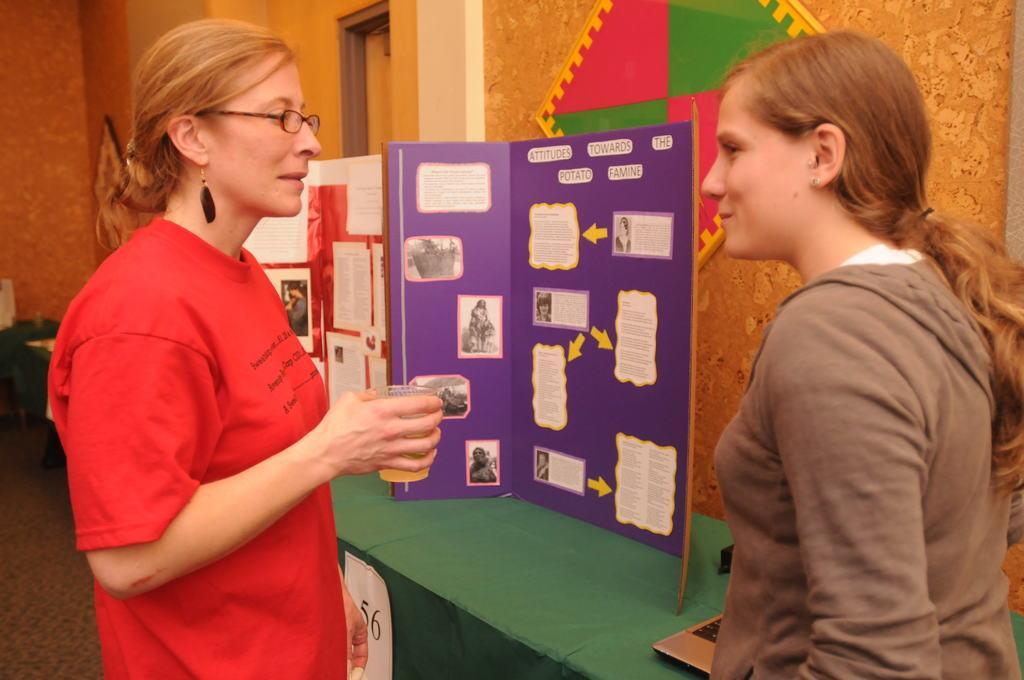In one or two sentences, can you explain what this image depicts? In this image I can see two people with different color dresses and one person is holding the glass. To the side of these people I can see the boards and the laptop on the green color surface. In the background I can see the green, red and yellow color board attached to the wall. 